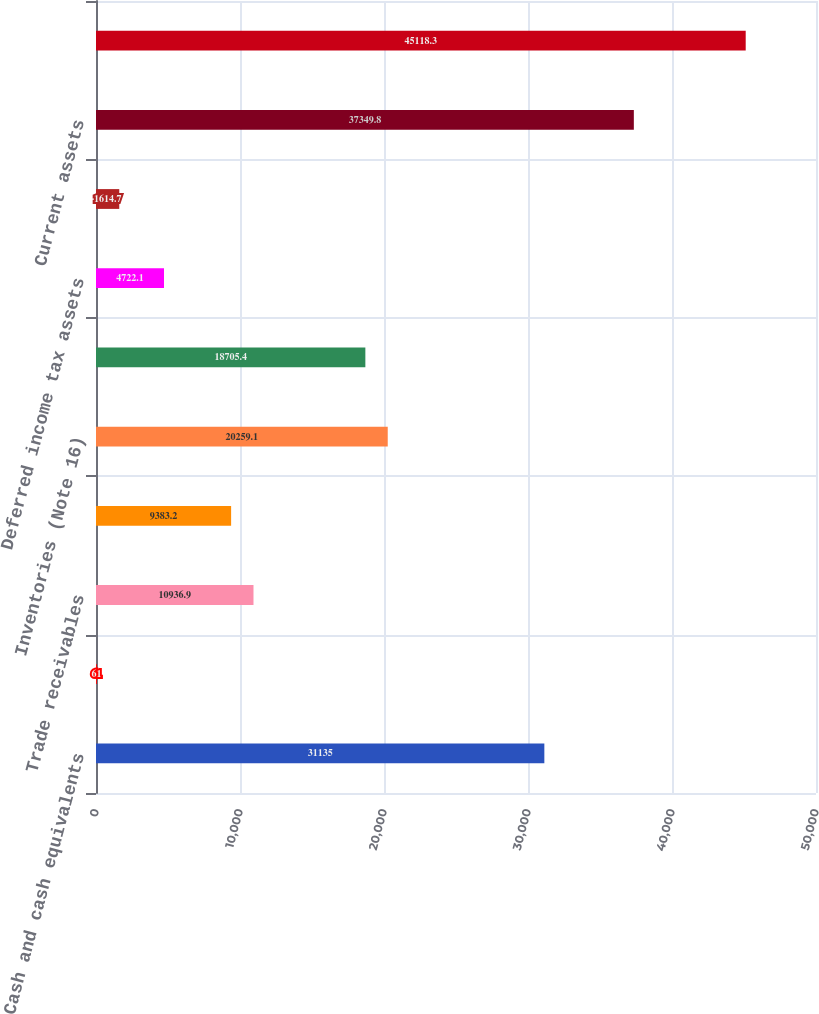Convert chart to OTSL. <chart><loc_0><loc_0><loc_500><loc_500><bar_chart><fcel>Cash and cash equivalents<fcel>Marketable securities and<fcel>Trade receivables<fcel>Accounts receivable<fcel>Inventories (Note 16)<fcel>Stockpiles and ore on leach<fcel>Deferred income tax assets<fcel>Other current assets (Note 18)<fcel>Current assets<fcel>Property plant and mine<nl><fcel>31135<fcel>61<fcel>10936.9<fcel>9383.2<fcel>20259.1<fcel>18705.4<fcel>4722.1<fcel>1614.7<fcel>37349.8<fcel>45118.3<nl></chart> 